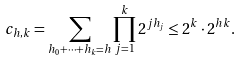Convert formula to latex. <formula><loc_0><loc_0><loc_500><loc_500>c _ { h , k } = \sum _ { h _ { 0 } + \dots + h _ { k } = h } \prod _ { j = 1 } ^ { k } 2 ^ { j h _ { j } } \leq 2 ^ { k } \cdot 2 ^ { h k } .</formula> 